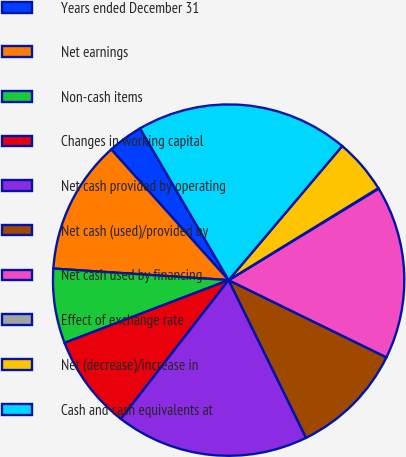Convert chart. <chart><loc_0><loc_0><loc_500><loc_500><pie_chart><fcel>Years ended December 31<fcel>Net earnings<fcel>Non-cash items<fcel>Changes in working capital<fcel>Net cash provided by operating<fcel>Net cash (used)/provided by<fcel>Net cash used by financing<fcel>Effect of exchange rate<fcel>Net (decrease)/increase in<fcel>Cash and cash equivalents at<nl><fcel>3.24%<fcel>12.3%<fcel>6.86%<fcel>8.68%<fcel>17.77%<fcel>10.49%<fcel>15.96%<fcel>0.05%<fcel>5.05%<fcel>19.59%<nl></chart> 